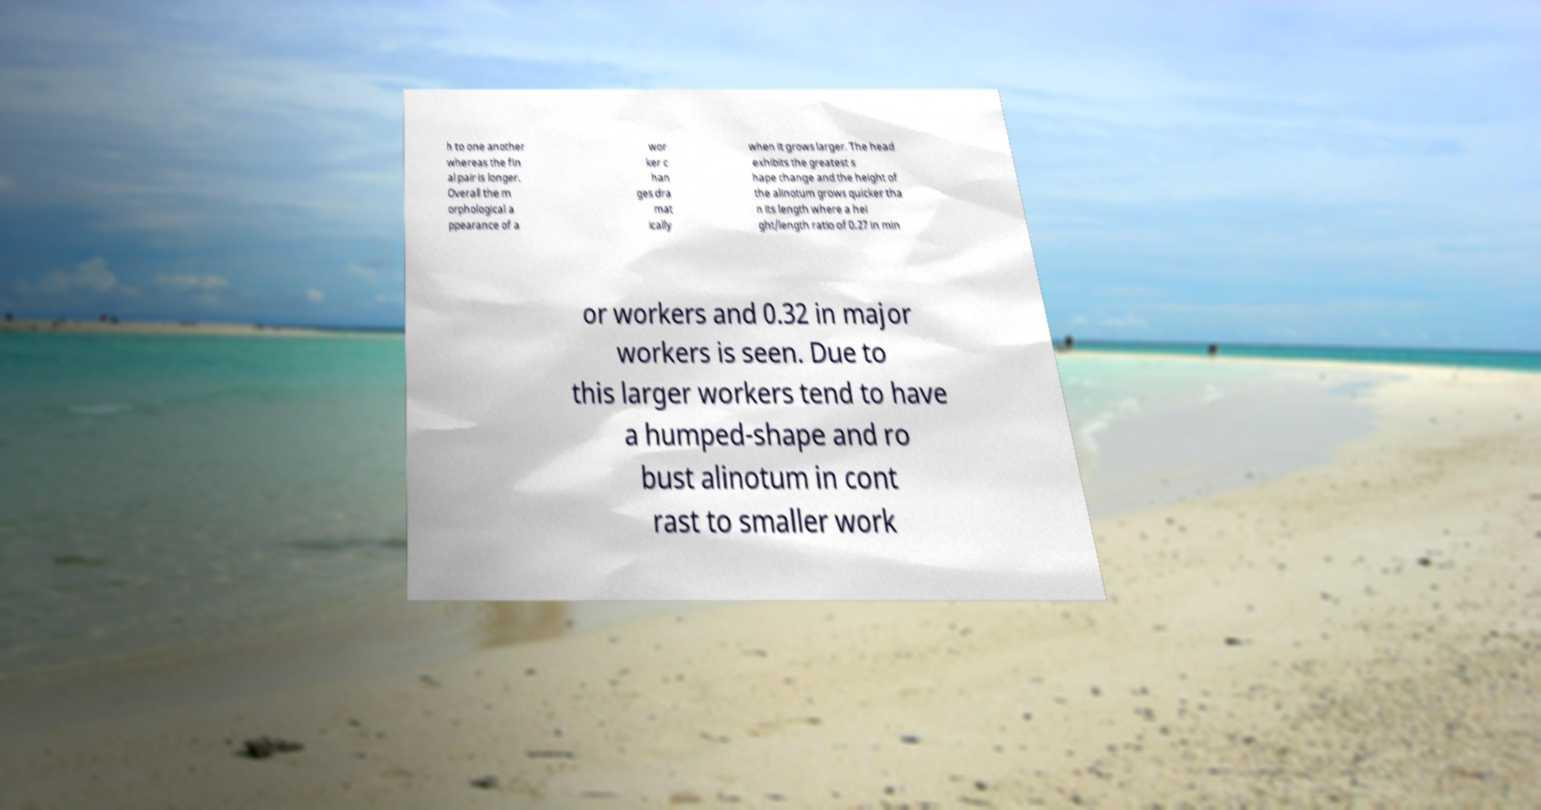I need the written content from this picture converted into text. Can you do that? h to one another whereas the fin al pair is longer. Overall the m orphological a ppearance of a wor ker c han ges dra mat ically when it grows larger. The head exhibits the greatest s hape change and the height of the alinotum grows quicker tha n its length where a hei ght/length ratio of 0.27 in min or workers and 0.32 in major workers is seen. Due to this larger workers tend to have a humped-shape and ro bust alinotum in cont rast to smaller work 